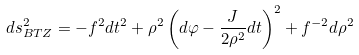<formula> <loc_0><loc_0><loc_500><loc_500>d s _ { B T Z } ^ { 2 } = - f ^ { 2 } d t ^ { 2 } + \rho ^ { 2 } \left ( d \varphi - { \frac { J } { 2 \rho ^ { 2 } } } d t \right ) ^ { 2 } + f ^ { - 2 } d \rho ^ { 2 }</formula> 